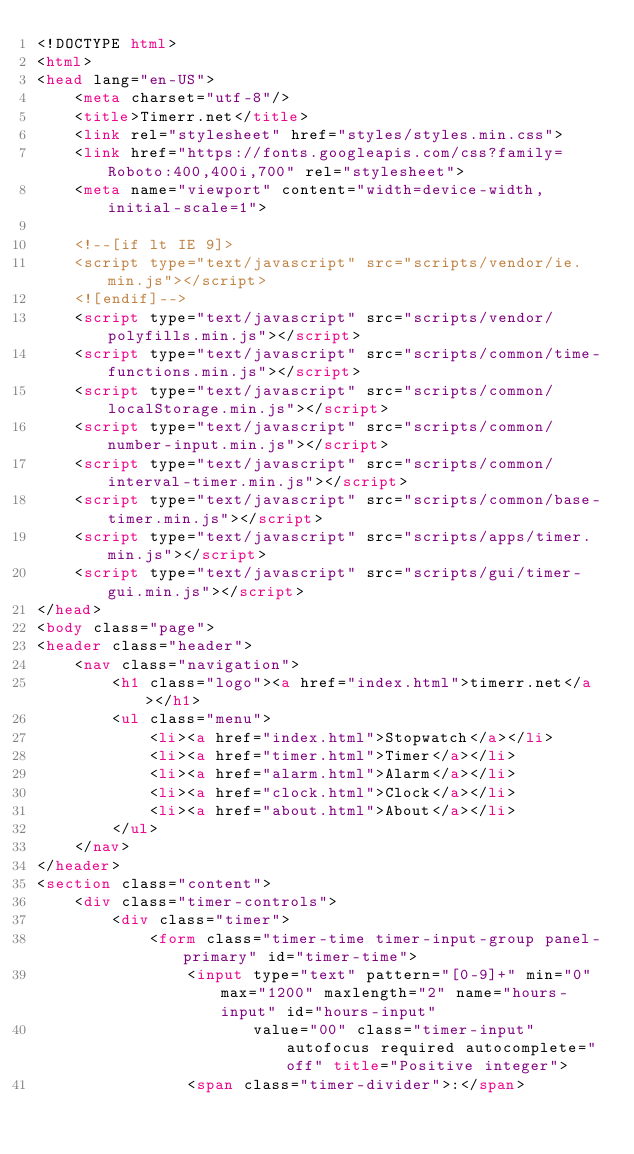Convert code to text. <code><loc_0><loc_0><loc_500><loc_500><_HTML_><!DOCTYPE html>
<html>
<head lang="en-US">
    <meta charset="utf-8"/>
    <title>Timerr.net</title>
    <link rel="stylesheet" href="styles/styles.min.css">
    <link href="https://fonts.googleapis.com/css?family=Roboto:400,400i,700" rel="stylesheet">
    <meta name="viewport" content="width=device-width, initial-scale=1">

    <!--[if lt IE 9]>
    <script type="text/javascript" src="scripts/vendor/ie.min.js"></script>
    <![endif]-->
    <script type="text/javascript" src="scripts/vendor/polyfills.min.js"></script>
    <script type="text/javascript" src="scripts/common/time-functions.min.js"></script>
    <script type="text/javascript" src="scripts/common/localStorage.min.js"></script>
    <script type="text/javascript" src="scripts/common/number-input.min.js"></script>
    <script type="text/javascript" src="scripts/common/interval-timer.min.js"></script>
    <script type="text/javascript" src="scripts/common/base-timer.min.js"></script>
    <script type="text/javascript" src="scripts/apps/timer.min.js"></script>
    <script type="text/javascript" src="scripts/gui/timer-gui.min.js"></script>
</head>
<body class="page">
<header class="header">
    <nav class="navigation">
        <h1 class="logo"><a href="index.html">timerr.net</a></h1>
        <ul class="menu">
            <li><a href="index.html">Stopwatch</a></li>
            <li><a href="timer.html">Timer</a></li>
            <li><a href="alarm.html">Alarm</a></li>
            <li><a href="clock.html">Clock</a></li>
            <li><a href="about.html">About</a></li>
        </ul>
    </nav>
</header>
<section class="content">
    <div class="timer-controls">
        <div class="timer">
            <form class="timer-time timer-input-group panel-primary" id="timer-time">
                <input type="text" pattern="[0-9]+" min="0" max="1200" maxlength="2" name="hours-input" id="hours-input"
                       value="00" class="timer-input" autofocus required autocomplete="off" title="Positive integer">
                <span class="timer-divider">:</span></code> 